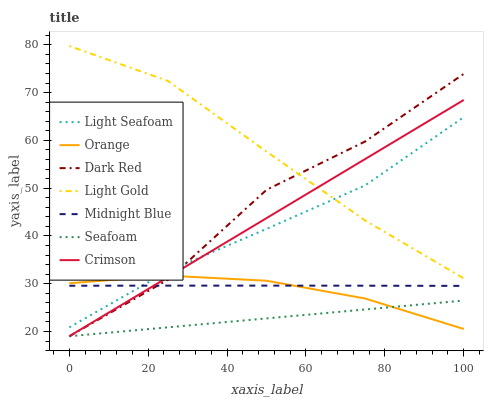Does Seafoam have the minimum area under the curve?
Answer yes or no. Yes. Does Light Gold have the maximum area under the curve?
Answer yes or no. Yes. Does Dark Red have the minimum area under the curve?
Answer yes or no. No. Does Dark Red have the maximum area under the curve?
Answer yes or no. No. Is Seafoam the smoothest?
Answer yes or no. Yes. Is Dark Red the roughest?
Answer yes or no. Yes. Is Dark Red the smoothest?
Answer yes or no. No. Is Seafoam the roughest?
Answer yes or no. No. Does Dark Red have the lowest value?
Answer yes or no. Yes. Does Orange have the lowest value?
Answer yes or no. No. Does Light Gold have the highest value?
Answer yes or no. Yes. Does Dark Red have the highest value?
Answer yes or no. No. Is Orange less than Light Gold?
Answer yes or no. Yes. Is Light Gold greater than Seafoam?
Answer yes or no. Yes. Does Light Gold intersect Dark Red?
Answer yes or no. Yes. Is Light Gold less than Dark Red?
Answer yes or no. No. Is Light Gold greater than Dark Red?
Answer yes or no. No. Does Orange intersect Light Gold?
Answer yes or no. No. 